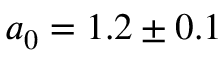<formula> <loc_0><loc_0><loc_500><loc_500>a _ { 0 } = 1 . 2 \pm 0 . 1</formula> 